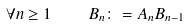Convert formula to latex. <formula><loc_0><loc_0><loc_500><loc_500>\forall n \geq 1 \quad B _ { n } \colon = A _ { n } B _ { n - 1 }</formula> 